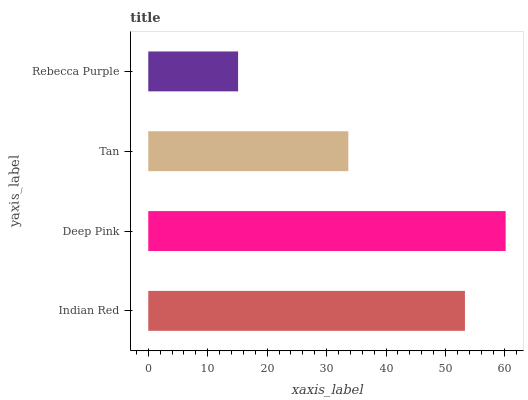Is Rebecca Purple the minimum?
Answer yes or no. Yes. Is Deep Pink the maximum?
Answer yes or no. Yes. Is Tan the minimum?
Answer yes or no. No. Is Tan the maximum?
Answer yes or no. No. Is Deep Pink greater than Tan?
Answer yes or no. Yes. Is Tan less than Deep Pink?
Answer yes or no. Yes. Is Tan greater than Deep Pink?
Answer yes or no. No. Is Deep Pink less than Tan?
Answer yes or no. No. Is Indian Red the high median?
Answer yes or no. Yes. Is Tan the low median?
Answer yes or no. Yes. Is Deep Pink the high median?
Answer yes or no. No. Is Deep Pink the low median?
Answer yes or no. No. 